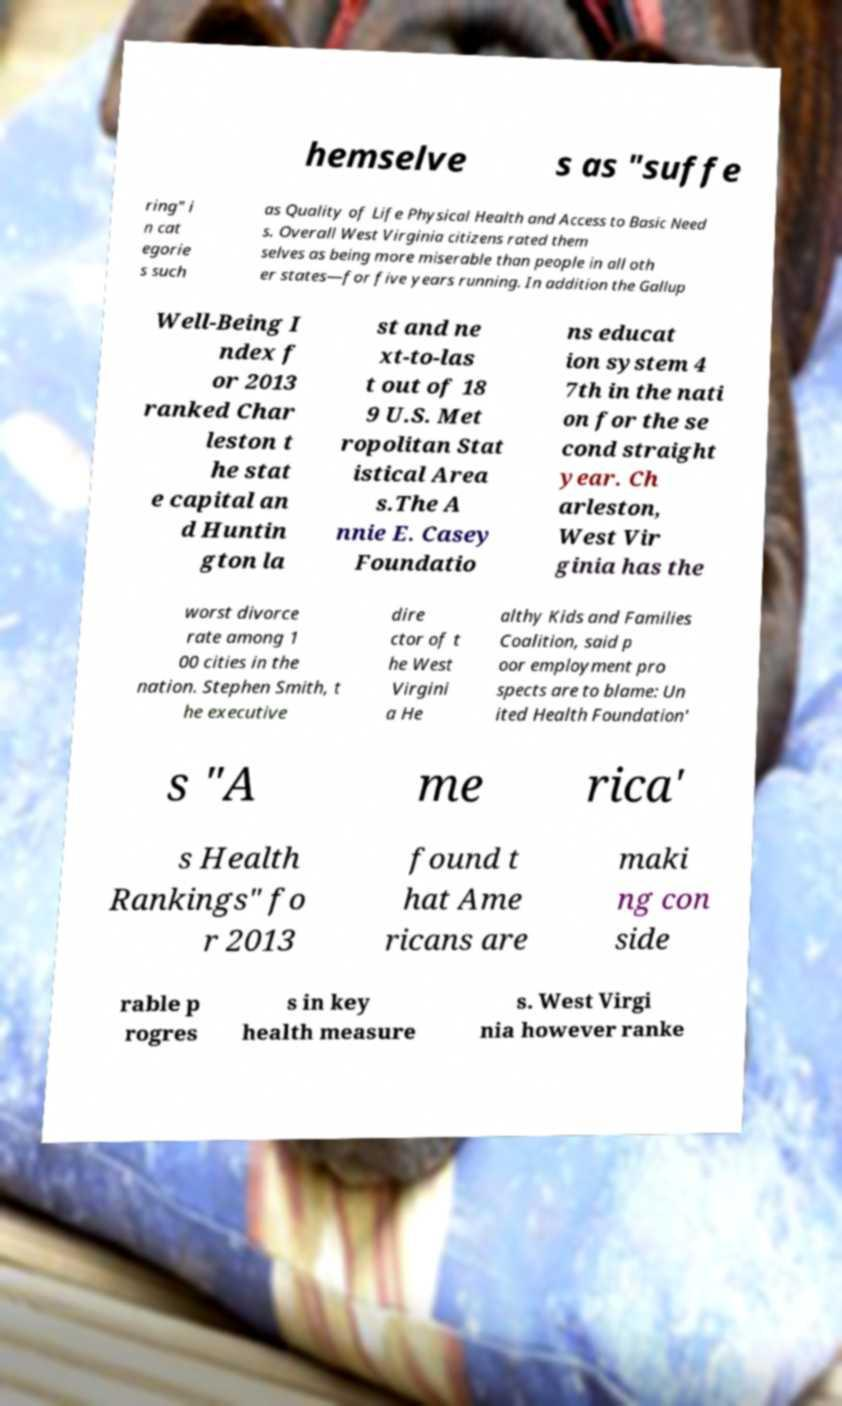What messages or text are displayed in this image? I need them in a readable, typed format. hemselve s as "suffe ring" i n cat egorie s such as Quality of Life Physical Health and Access to Basic Need s. Overall West Virginia citizens rated them selves as being more miserable than people in all oth er states—for five years running. In addition the Gallup Well-Being I ndex f or 2013 ranked Char leston t he stat e capital an d Huntin gton la st and ne xt-to-las t out of 18 9 U.S. Met ropolitan Stat istical Area s.The A nnie E. Casey Foundatio ns educat ion system 4 7th in the nati on for the se cond straight year. Ch arleston, West Vir ginia has the worst divorce rate among 1 00 cities in the nation. Stephen Smith, t he executive dire ctor of t he West Virgini a He althy Kids and Families Coalition, said p oor employment pro spects are to blame: Un ited Health Foundation' s "A me rica' s Health Rankings" fo r 2013 found t hat Ame ricans are maki ng con side rable p rogres s in key health measure s. West Virgi nia however ranke 